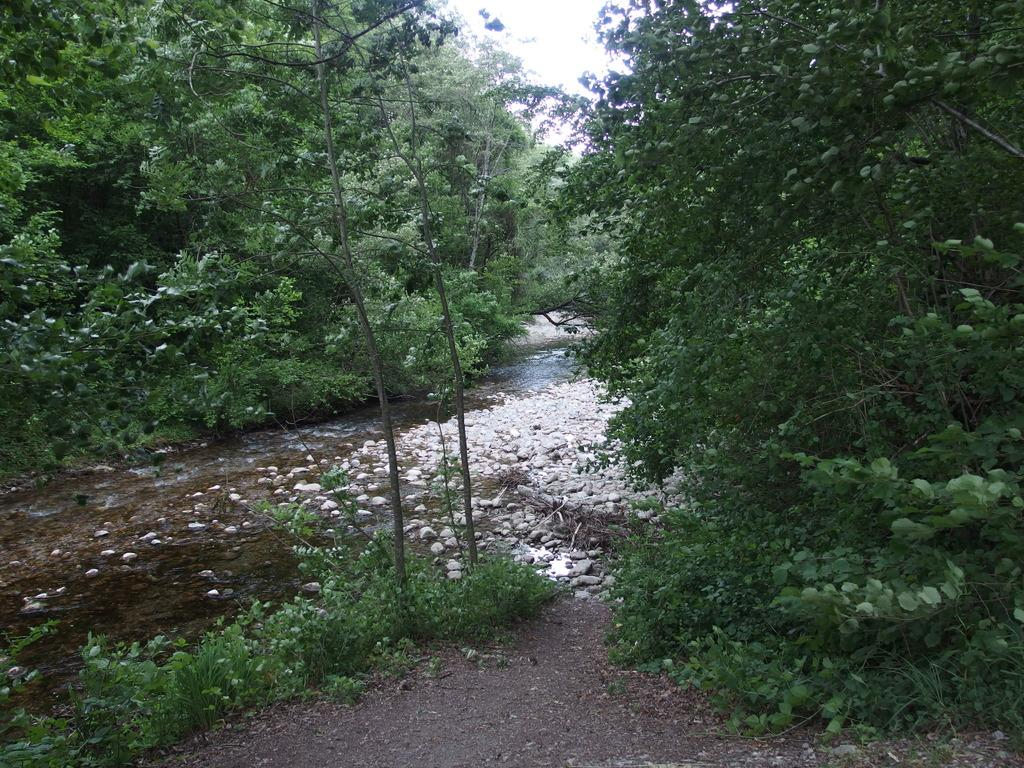What type of vegetation can be seen in the image? There are trees and plants in the image. What other elements can be found in the image? There are stones and water visible in the image. What is visible at the top of the image? The sky is visible at the top of the image. How many cracks can be seen in the water in the image? There are no cracks visible in the water in the image. Can you describe the bee's behavior in the image? There are no bees present in the image. 